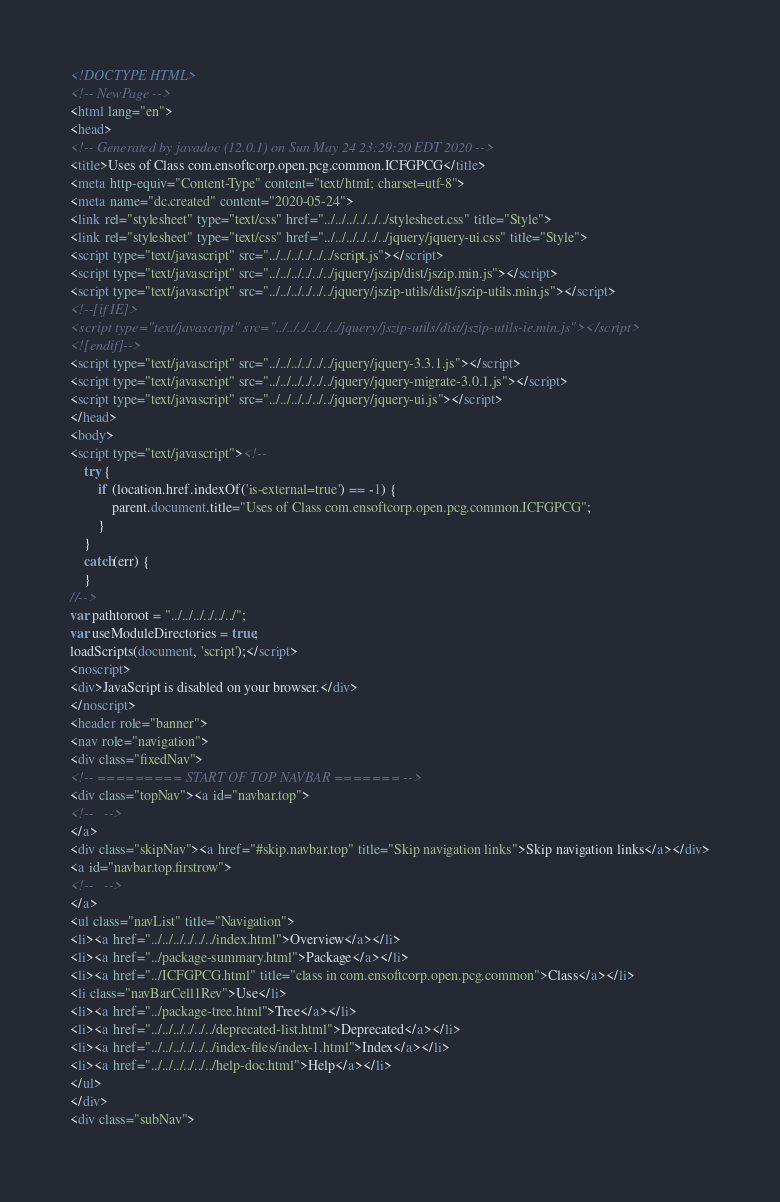<code> <loc_0><loc_0><loc_500><loc_500><_HTML_><!DOCTYPE HTML>
<!-- NewPage -->
<html lang="en">
<head>
<!-- Generated by javadoc (12.0.1) on Sun May 24 23:29:20 EDT 2020 -->
<title>Uses of Class com.ensoftcorp.open.pcg.common.ICFGPCG</title>
<meta http-equiv="Content-Type" content="text/html; charset=utf-8">
<meta name="dc.created" content="2020-05-24">
<link rel="stylesheet" type="text/css" href="../../../../../../stylesheet.css" title="Style">
<link rel="stylesheet" type="text/css" href="../../../../../../jquery/jquery-ui.css" title="Style">
<script type="text/javascript" src="../../../../../../script.js"></script>
<script type="text/javascript" src="../../../../../../jquery/jszip/dist/jszip.min.js"></script>
<script type="text/javascript" src="../../../../../../jquery/jszip-utils/dist/jszip-utils.min.js"></script>
<!--[if IE]>
<script type="text/javascript" src="../../../../../../jquery/jszip-utils/dist/jszip-utils-ie.min.js"></script>
<![endif]-->
<script type="text/javascript" src="../../../../../../jquery/jquery-3.3.1.js"></script>
<script type="text/javascript" src="../../../../../../jquery/jquery-migrate-3.0.1.js"></script>
<script type="text/javascript" src="../../../../../../jquery/jquery-ui.js"></script>
</head>
<body>
<script type="text/javascript"><!--
    try {
        if (location.href.indexOf('is-external=true') == -1) {
            parent.document.title="Uses of Class com.ensoftcorp.open.pcg.common.ICFGPCG";
        }
    }
    catch(err) {
    }
//-->
var pathtoroot = "../../../../../../";
var useModuleDirectories = true;
loadScripts(document, 'script');</script>
<noscript>
<div>JavaScript is disabled on your browser.</div>
</noscript>
<header role="banner">
<nav role="navigation">
<div class="fixedNav">
<!-- ========= START OF TOP NAVBAR ======= -->
<div class="topNav"><a id="navbar.top">
<!--   -->
</a>
<div class="skipNav"><a href="#skip.navbar.top" title="Skip navigation links">Skip navigation links</a></div>
<a id="navbar.top.firstrow">
<!--   -->
</a>
<ul class="navList" title="Navigation">
<li><a href="../../../../../../index.html">Overview</a></li>
<li><a href="../package-summary.html">Package</a></li>
<li><a href="../ICFGPCG.html" title="class in com.ensoftcorp.open.pcg.common">Class</a></li>
<li class="navBarCell1Rev">Use</li>
<li><a href="../package-tree.html">Tree</a></li>
<li><a href="../../../../../../deprecated-list.html">Deprecated</a></li>
<li><a href="../../../../../../index-files/index-1.html">Index</a></li>
<li><a href="../../../../../../help-doc.html">Help</a></li>
</ul>
</div>
<div class="subNav"></code> 